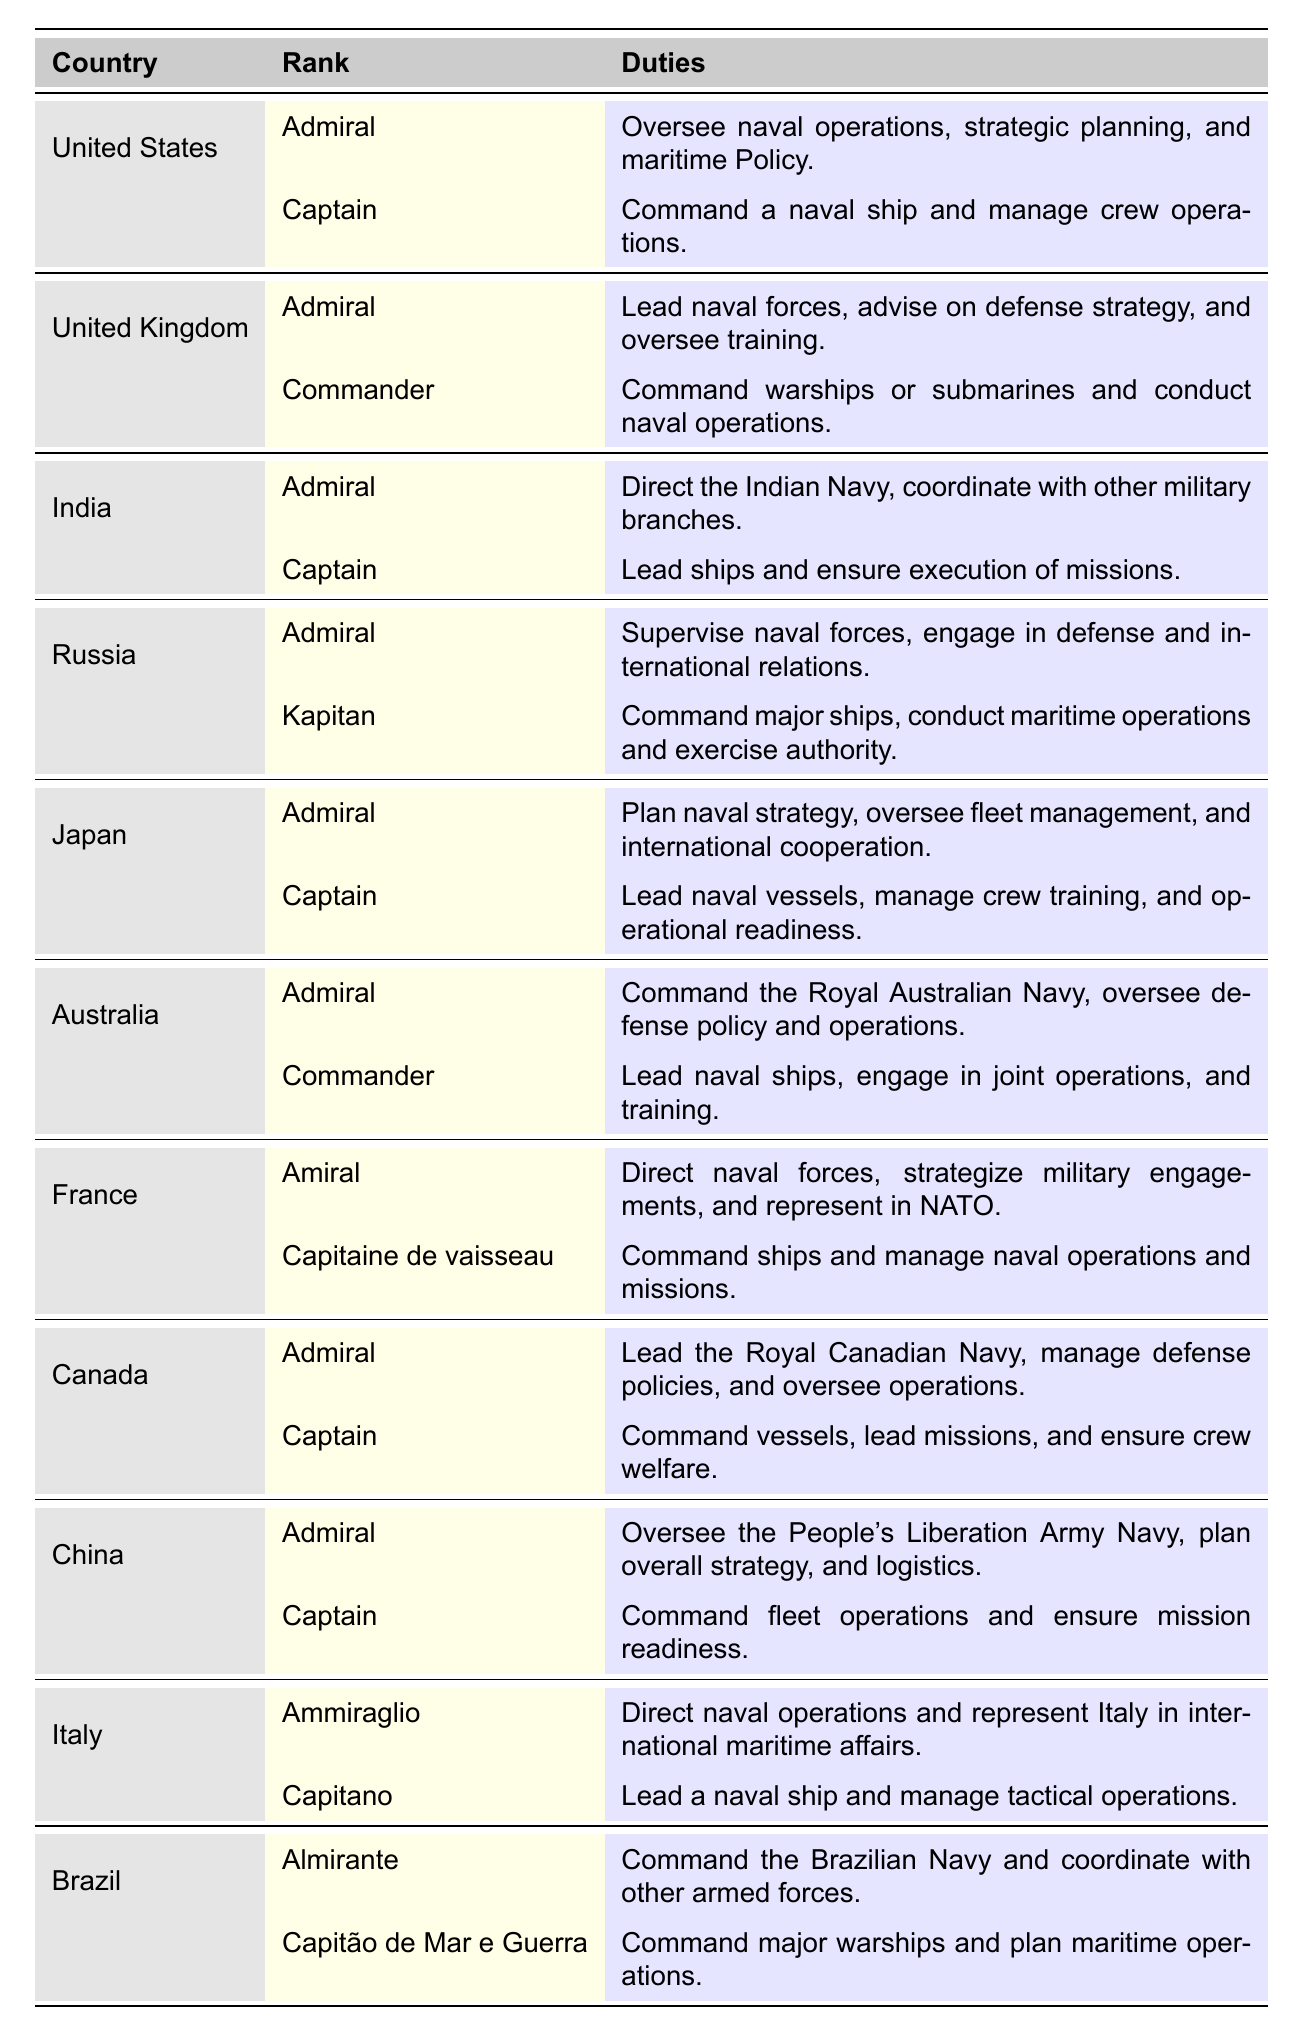What is the rank for the naval officer from Brazil? From the table, the ranks for Brazil are "Almirante" and "Capitão de Mar e Guerra".
Answer: Almirante and Capitão de Mar e Guerra What duties does an Admiral in the United Kingdom perform? According to the table, the Admiral in the United Kingdom leads naval forces, advises on defense strategy, and oversees training.
Answer: Leads naval forces, advises on defense strategy, and oversees training How many different naval ranks are listed for India? The table shows that India has two naval ranks: "Admiral" and "Captain".
Answer: Two Is there a rank called "Kapitan" in any other country besides Russia? The table indicates that "Kapitan" is uniquely listed under Russia and doesn't appear for any other country.
Answer: No Which country has a rank "Ammiraglio"? The table specifies that Italy has the rank "Ammiraglio".
Answer: Italy List the duties associated with the rank of Captain in the United States. From the table, the duty associated with the rank of Captain in the United States is to command a naval ship and manage crew operations.
Answer: Command a naval ship and manage crew operations What is the total number of countries that have the rank of Admiral? By reviewing the table, the countries listed with the rank of Admiral are the United States, the United Kingdom, India, Russia, Japan, Australia, France, Canada, China, and Italy, totaling 10 countries.
Answer: 10 Which country leads the Royal Canadian Navy? The table states that Canada has the rank "Admiral" which leads the Royal Canadian Navy, thus the country is Canada.
Answer: Canada Does Japan have a Commander rank? Yes, the table confirms that Japan has the rank "Captain" but does not list "Commander", therefore the answer is yes.
Answer: Yes Which country oversees maritime operations and exercises authority with the rank of Kapitan? The table identifies Russia as the country that has the rank of "Kapitan" associated with overseeing maritime operations and exercising authority.
Answer: Russia Based on the table, which country has the same duties for its Admiral as the United States? The duties of the Admiral in the United States and the Admiral in Australia appear similar, focusing on command and oversight of naval operations.
Answer: Australia Which two ranks are associated with the country of China? The ranks associated with China in the table are "Admiral" and "Captain".
Answer: Admiral and Captain 